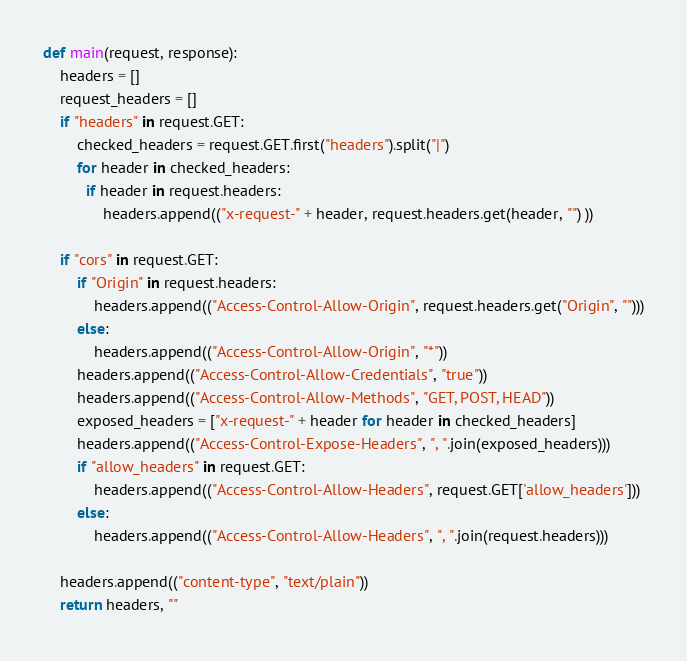Convert code to text. <code><loc_0><loc_0><loc_500><loc_500><_Python_>def main(request, response):
    headers = []
    request_headers = []
    if "headers" in request.GET:
        checked_headers = request.GET.first("headers").split("|")
        for header in checked_headers:
          if header in request.headers:
              headers.append(("x-request-" + header, request.headers.get(header, "") ))

    if "cors" in request.GET:
        if "Origin" in request.headers:
            headers.append(("Access-Control-Allow-Origin", request.headers.get("Origin", "")))
        else:
            headers.append(("Access-Control-Allow-Origin", "*"))
        headers.append(("Access-Control-Allow-Credentials", "true"))
        headers.append(("Access-Control-Allow-Methods", "GET, POST, HEAD"))
        exposed_headers = ["x-request-" + header for header in checked_headers]
        headers.append(("Access-Control-Expose-Headers", ", ".join(exposed_headers)))
        if "allow_headers" in request.GET:
            headers.append(("Access-Control-Allow-Headers", request.GET['allow_headers']))
        else:
            headers.append(("Access-Control-Allow-Headers", ", ".join(request.headers)))

    headers.append(("content-type", "text/plain"))
    return headers, ""
</code> 